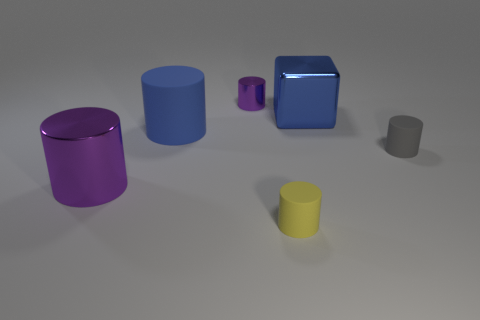Is the shape of the thing left of the large matte cylinder the same as the large blue object on the left side of the big metal block?
Provide a short and direct response. Yes. There is a small purple object; what number of small cylinders are in front of it?
Keep it short and to the point. 2. Are there any big cyan spheres that have the same material as the blue cylinder?
Keep it short and to the point. No. There is a purple cylinder that is the same size as the blue shiny thing; what is its material?
Your response must be concise. Metal. Is the material of the yellow object the same as the big purple cylinder?
Offer a terse response. No. What number of things are either large blue objects or blue rubber things?
Give a very brief answer. 2. There is a tiny object in front of the small gray object; what shape is it?
Make the answer very short. Cylinder. There is a small cylinder that is made of the same material as the big block; what color is it?
Ensure brevity in your answer.  Purple. There is a big purple object that is the same shape as the yellow object; what material is it?
Provide a short and direct response. Metal. What shape is the gray rubber object?
Offer a very short reply. Cylinder. 